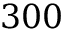Convert formula to latex. <formula><loc_0><loc_0><loc_500><loc_500>3 0 0</formula> 